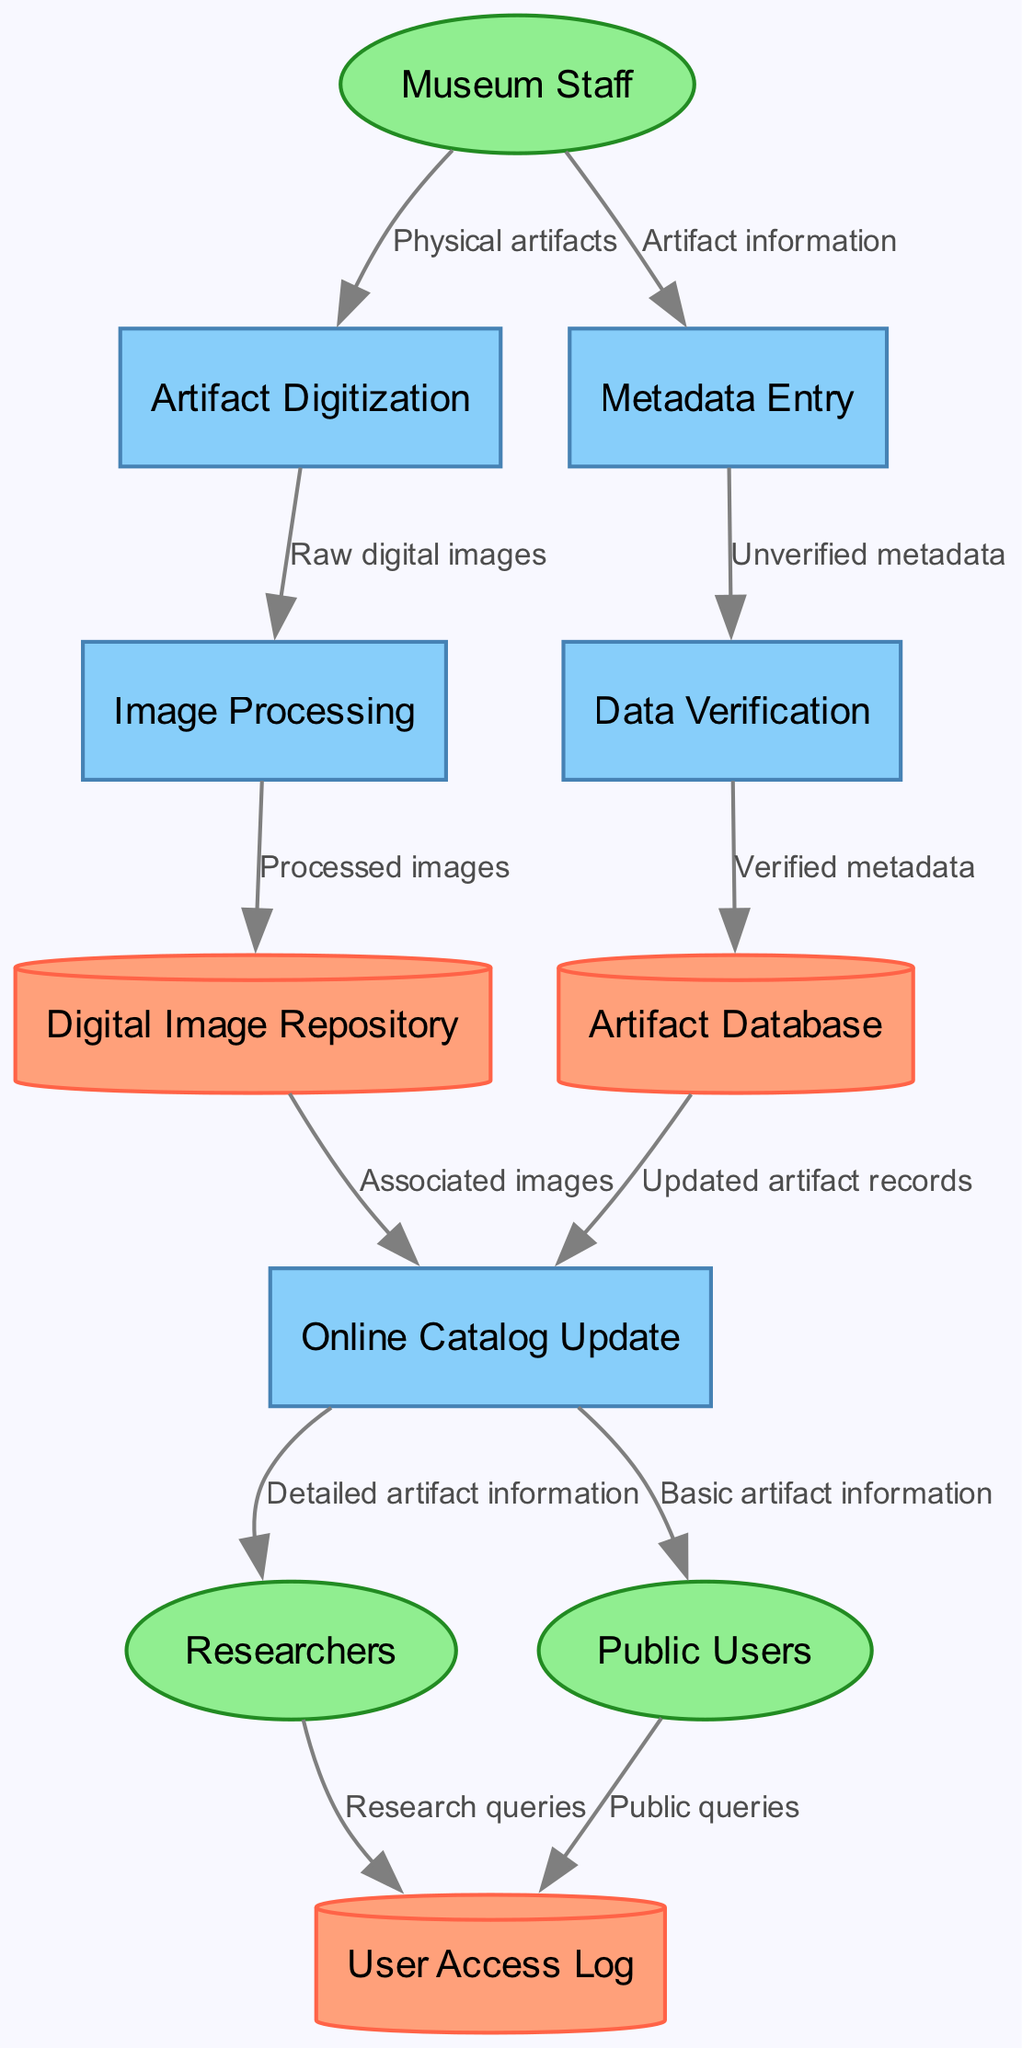What is the first process in the diagram? The first process listed in the diagram under "processes" is "Artifact Digitization." This is determined by referencing the order of the processes provided in the diagram data.
Answer: Artifact Digitization How many external entities are depicted in the diagram? The diagram indicates there are three external entities: "Museum Staff," "Researchers," and "Public Users." By counting these entities in the provided data, we confirm the total.
Answer: 3 Which process receives "Physical artifacts" as input? "Physical artifacts" flows from "Museum Staff" to "Artifact Digitization." By tracing the data flow from the external entity to the process, we see this connection.
Answer: Artifact Digitization What type of node is "Digital Image Repository"? "Digital Image Repository" is categorized as a data store, as indicated in the provided information about different node types. Specifically, this node type is described as a cylinder in the diagram.
Answer: Cylinder What is the output from the "Data Verification" process? The output from "Data Verification" is "Verified metadata," which moves to the "Artifact Database." By examining the data flow from the verification process, we identify the direct output.
Answer: Verified metadata How are "Public queries" logged in the system? "Public queries" come from "Public Users" and flow to the "User Access Log." This connection is shown clearly in the diagram and helps identify how public interactions are recorded.
Answer: User Access Log What happens to the "Processed images" after "Image Processing"? After "Image Processing," the "Processed images" flow into the "Digital Image Repository." By following the order of processing and the subsequent data flow, we observe where these images are stored.
Answer: Digital Image Repository Which external entity receives "Detailed artifact information"? "Detailed artifact information" is sent to "Researchers" from the "Online Catalog Update." This flow is traced in the diagram, showing the direct relationship between the catalog update and the researchers.
Answer: Researchers Which data store holds "Updated artifact records"? The "Updated artifact records" are stored in the "Artifact Database." By analyzing the flow from the "Online Catalog Update" process, we see where this specific data is kept.
Answer: Artifact Database 